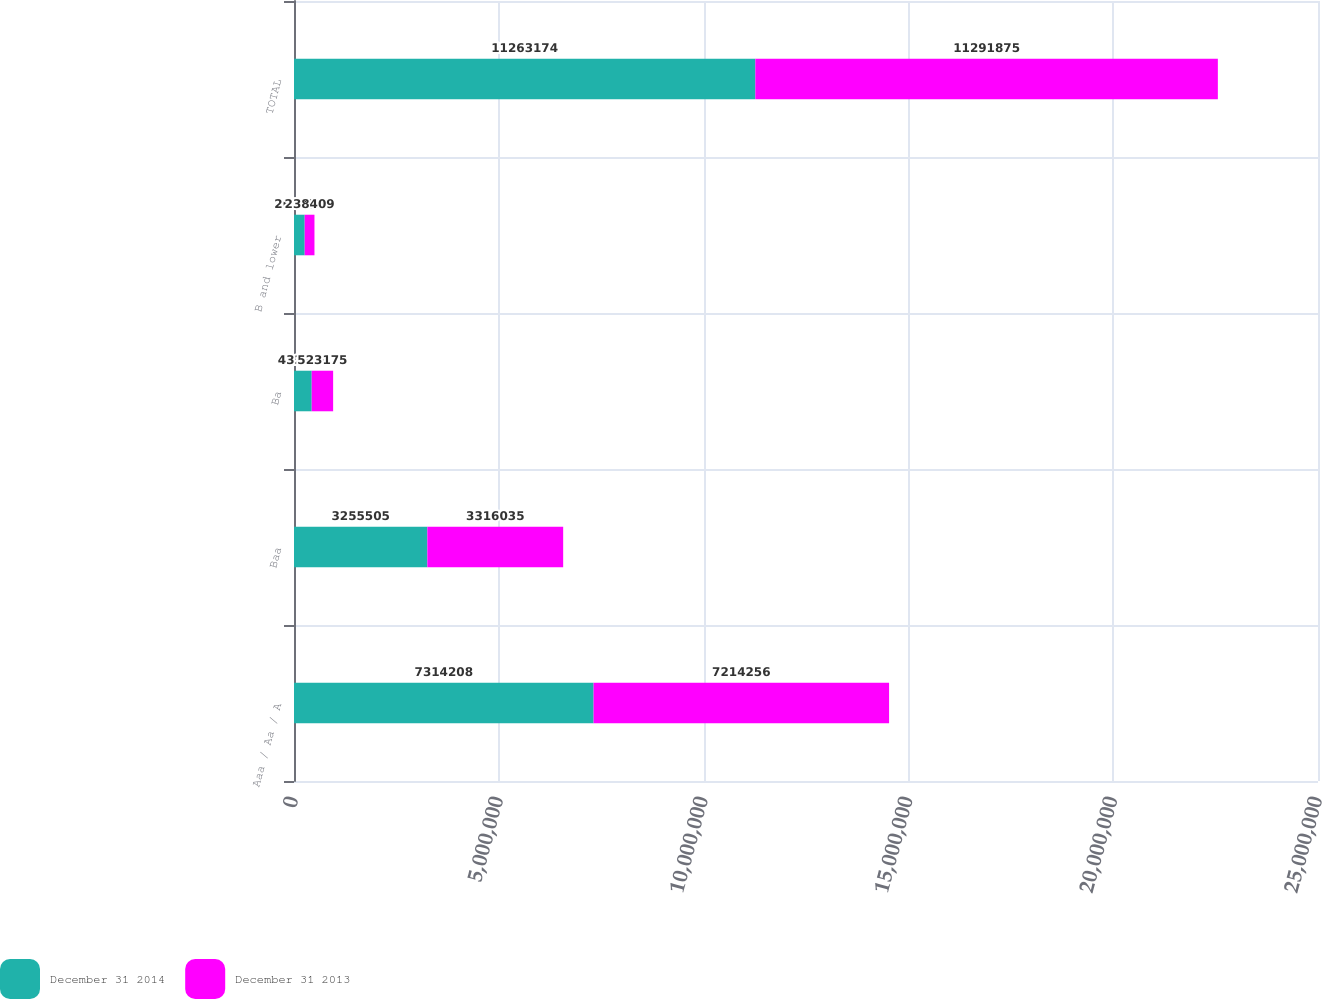Convert chart to OTSL. <chart><loc_0><loc_0><loc_500><loc_500><stacked_bar_chart><ecel><fcel>Aaa / Aa / A<fcel>Baa<fcel>Ba<fcel>B and lower<fcel>TOTAL<nl><fcel>December 31 2014<fcel>7.31421e+06<fcel>3.2555e+06<fcel>432203<fcel>261258<fcel>1.12632e+07<nl><fcel>December 31 2013<fcel>7.21426e+06<fcel>3.31604e+06<fcel>523175<fcel>238409<fcel>1.12919e+07<nl></chart> 